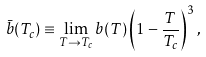<formula> <loc_0><loc_0><loc_500><loc_500>\bar { b } ( T _ { c } ) \equiv \lim _ { T \to T _ { c } } b ( T ) \left ( 1 - \frac { T } { T _ { c } } \right ) ^ { 3 } ,</formula> 